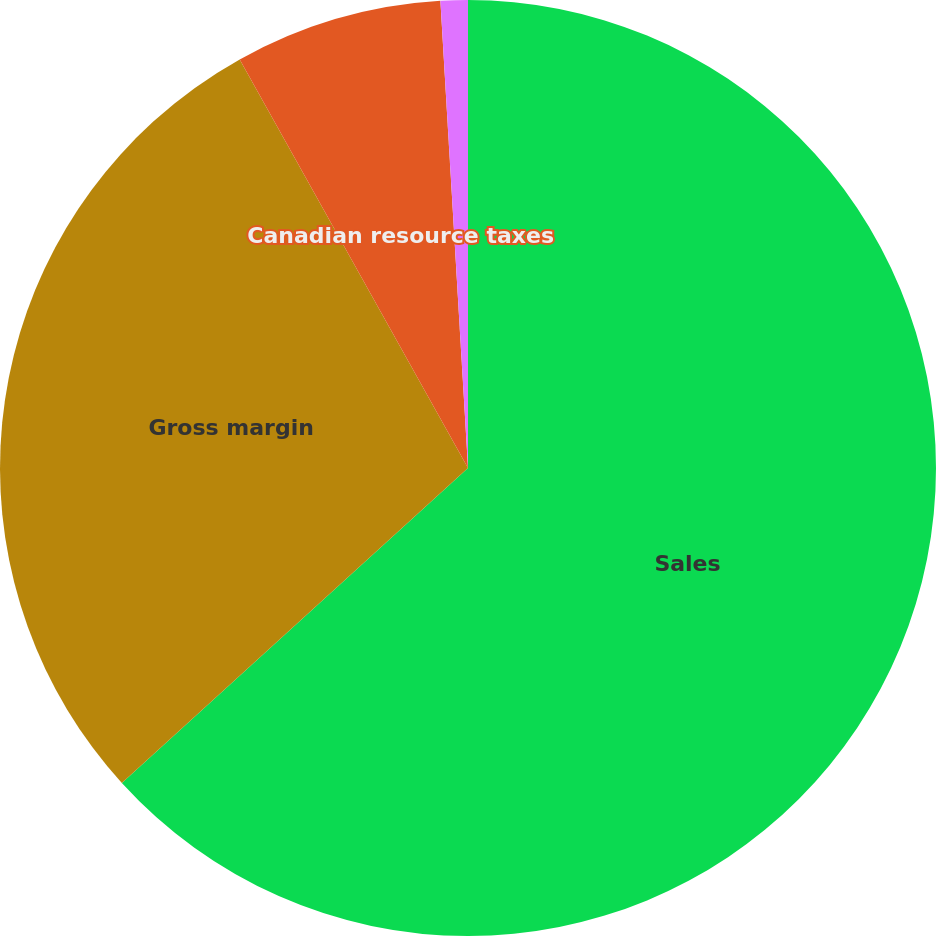Convert chart to OTSL. <chart><loc_0><loc_0><loc_500><loc_500><pie_chart><fcel>Sales<fcel>Gross margin<fcel>Canadian resource taxes<fcel>Gross margin (excluding CRT)<nl><fcel>63.25%<fcel>28.64%<fcel>7.17%<fcel>0.94%<nl></chart> 